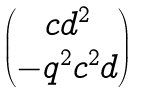<formula> <loc_0><loc_0><loc_500><loc_500>\begin{pmatrix} c d ^ { 2 } \\ - q ^ { 2 } c ^ { 2 } d \end{pmatrix}</formula> 